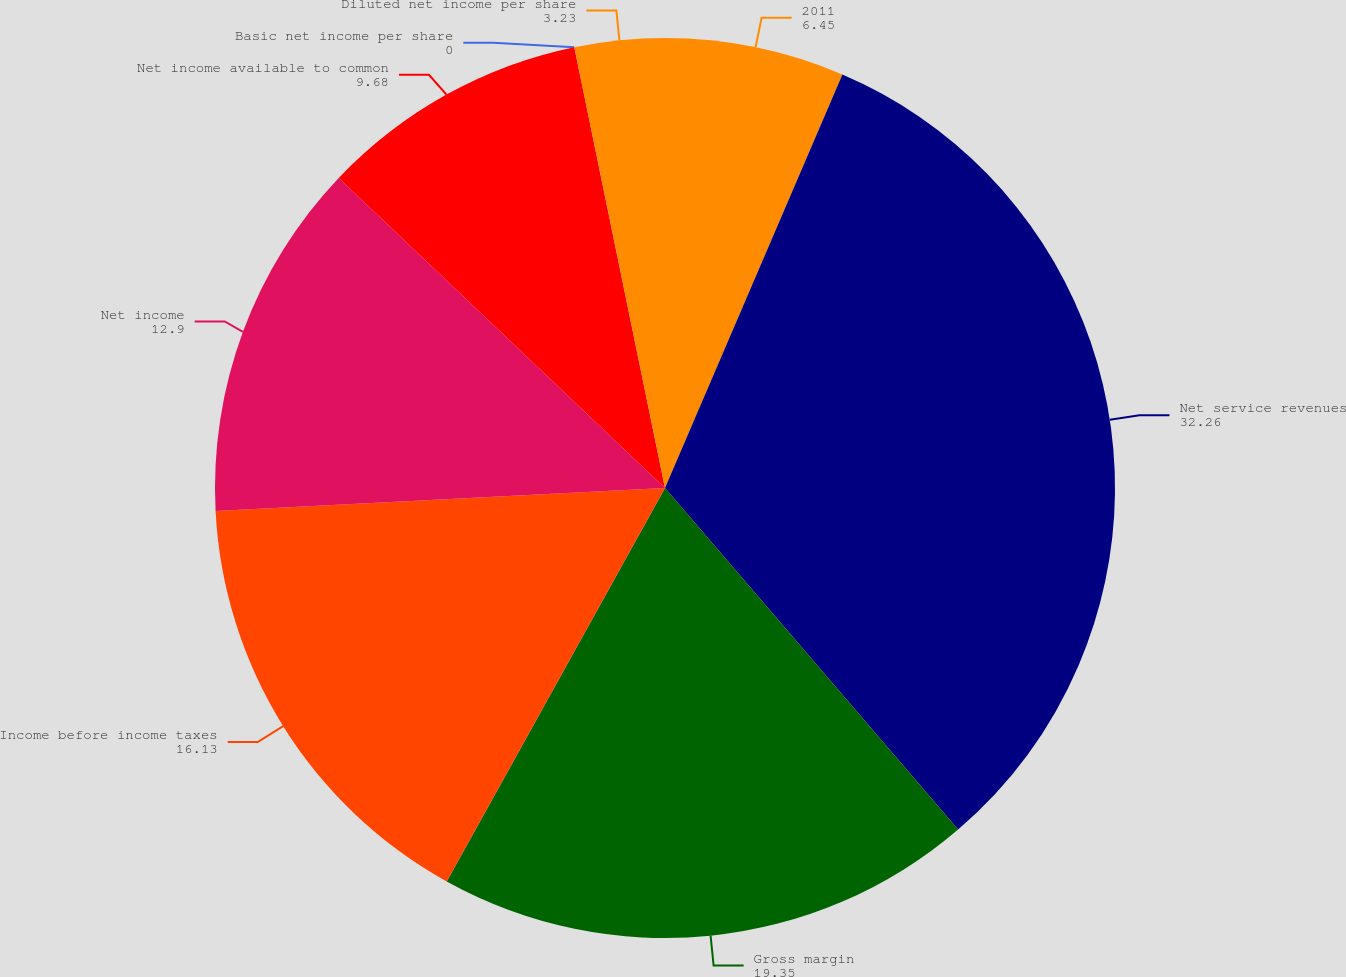Convert chart to OTSL. <chart><loc_0><loc_0><loc_500><loc_500><pie_chart><fcel>2011<fcel>Net service revenues<fcel>Gross margin<fcel>Income before income taxes<fcel>Net income<fcel>Net income available to common<fcel>Basic net income per share<fcel>Diluted net income per share<nl><fcel>6.45%<fcel>32.26%<fcel>19.35%<fcel>16.13%<fcel>12.9%<fcel>9.68%<fcel>0.0%<fcel>3.23%<nl></chart> 